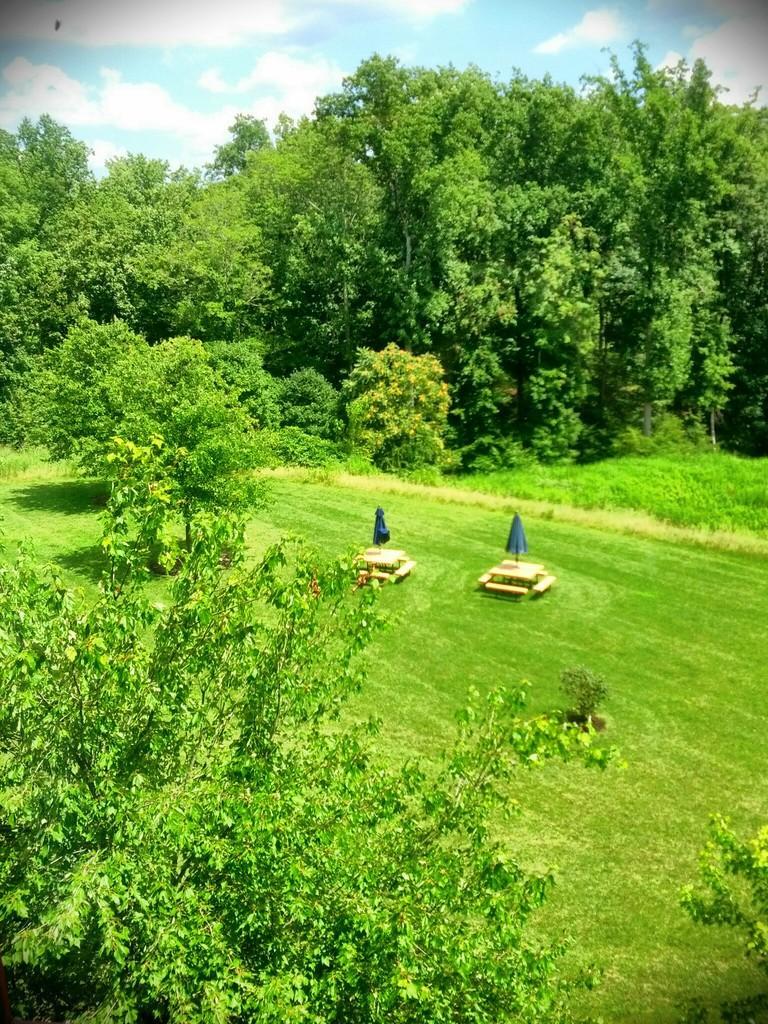Describe this image in one or two sentences. In this image there are trees and there are tables are arranged on the surface of the grass. In the background there is a sky. 